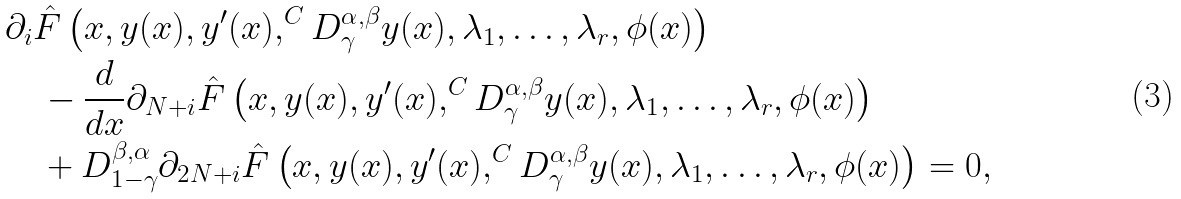Convert formula to latex. <formula><loc_0><loc_0><loc_500><loc_500>& \partial _ { i } \hat { F } \left ( x , y ( x ) , y ^ { \prime } ( x ) , ^ { C } D ^ { \alpha , \beta } _ { \gamma } y ( x ) , \lambda _ { 1 } , \dots , \lambda _ { r } , \phi ( x ) \right ) \\ & \quad - \frac { d } { d x } \partial _ { N + i } \hat { F } \left ( x , y ( x ) , y ^ { \prime } ( x ) , ^ { C } D ^ { \alpha , \beta } _ { \gamma } y ( x ) , \lambda _ { 1 } , \dots , \lambda _ { r } , \phi ( x ) \right ) \\ & \quad + D ^ { \beta , \alpha } _ { 1 - \gamma } \partial _ { 2 N + i } \hat { F } \left ( x , y ( x ) , y ^ { \prime } ( x ) , ^ { C } D ^ { \alpha , \beta } _ { \gamma } y ( x ) , \lambda _ { 1 } , \dots , \lambda _ { r } , \phi ( x ) \right ) = 0 ,</formula> 